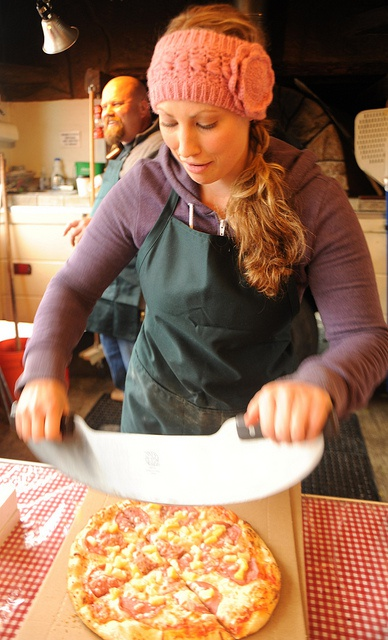Describe the objects in this image and their specific colors. I can see people in black, maroon, gray, and red tones, dining table in black, white, salmon, and red tones, knife in black, white, tan, and darkgray tones, pizza in black, khaki, orange, lightyellow, and gold tones, and pizza in black, orange, khaki, and lightyellow tones in this image. 